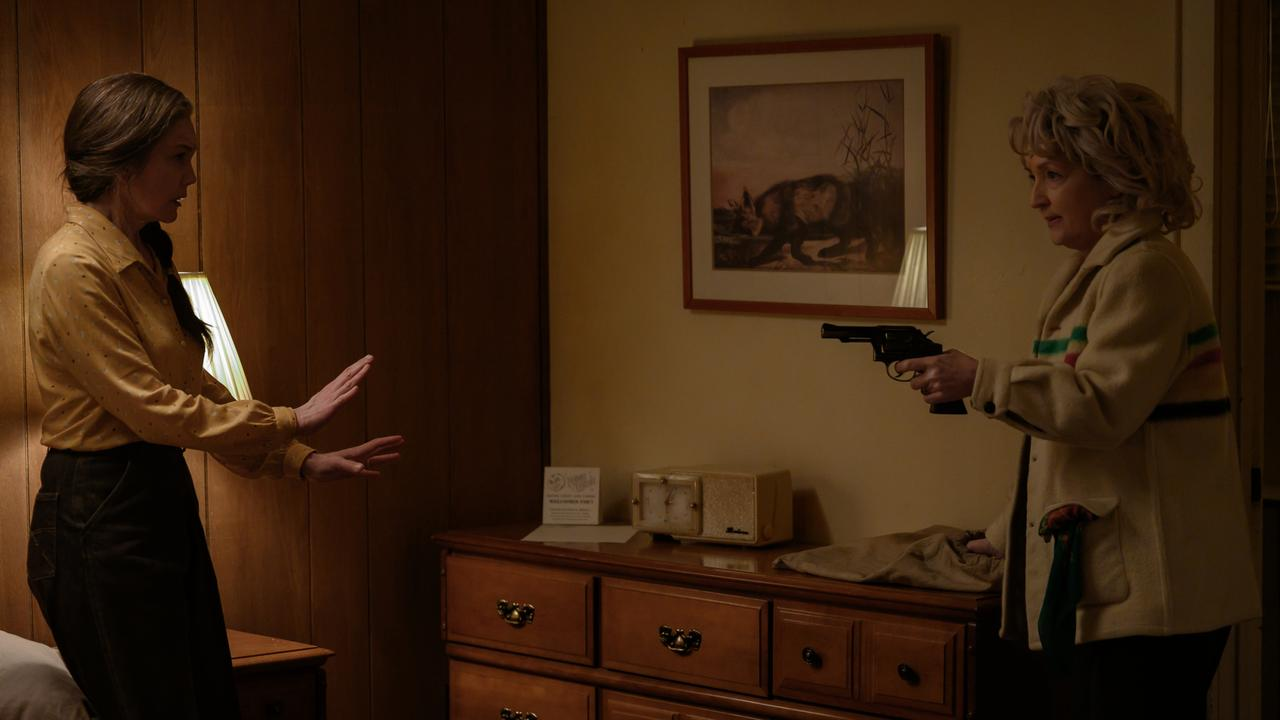What could be the backstory leading to this confrontation? The backstory of this confrontation could stem from a deep betrayal. The woman holding the gun, who once trusted and loved the other woman, may have discovered a dark secret. Perhaps the woman in the yellow blouse was involved in a conspiracy that endangered their lives or shared a close bond with someone who harmed the woman with the gun. The indications of trust breaking down over time, such as clandestine meetings, whispered phone calls, and hidden documents, could have led to this climactic showdown, with the room itself standing witness to the erosion of their relationship. Describe how the lighting in the room contributes to the tension of the scene. The lighting in the room is dim but strategically placed to heighten the drama and tension of the scene. The single lamp on the nightstand casts a soft, almost eerie glow, accentuating the faces of the women and highlighting their emotions. Shadows play across the wooden panels, creating an atmosphere of suspense and uncertainty. The limited light source emphasizes the isolation of the room, making the confrontation feel more intimate and intense, as if time has slowed down and every moment is charged with impending danger. Imagine this scene is part of a mystery thriller. What are some potential plot twists that could follow? In a mystery thriller, several intriguing plot twists could follow this scene:
1. The woman in the yellow blouse confesses to being framed, revealing that there is a third person manipulating both of them, setting the stage for a collaboration to uncover the truth.
2. The gun, upon closer inspection, is found to be unloaded, indicating the woman holding it never intended to kill but to scare the other into confessing something crucial.
3. A hidden recording device in the room captures the entire confrontation, and later it is found out that the real culprit planted it to blackmail both women.
4. The woman in the cream-colored jacket is revealed to be an undercover agent, and this confrontation is part of a larger, intricate sting operation to bring down a criminal organization. 